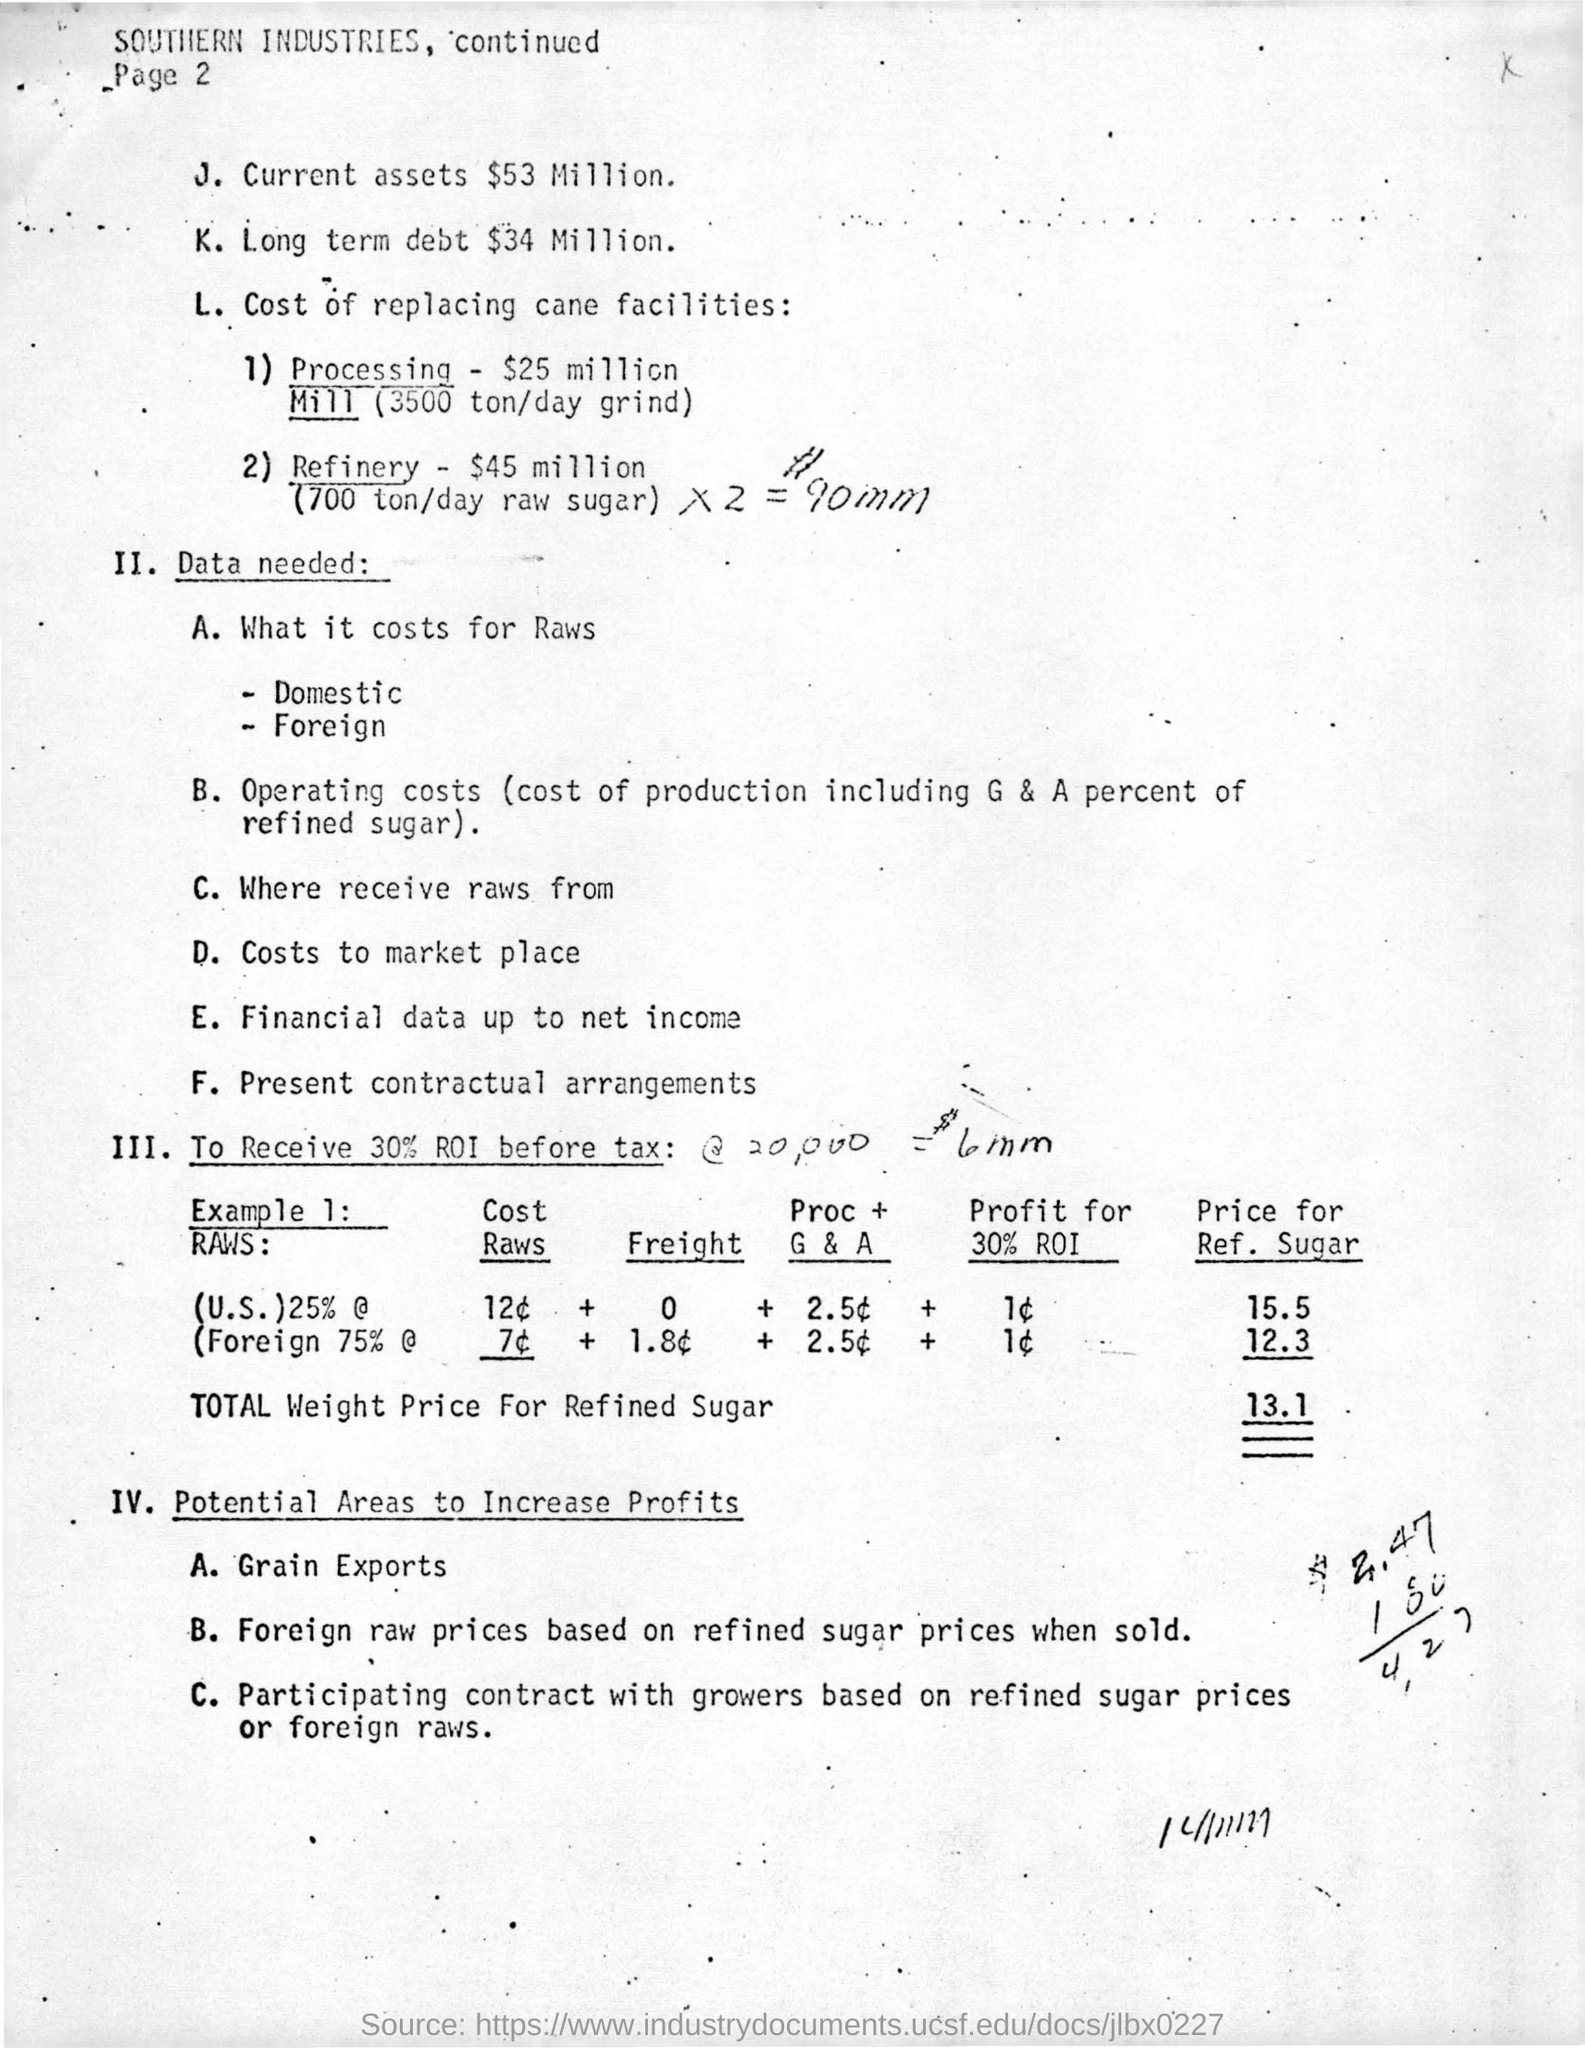What is the total weight price for refined sugar ?
Give a very brief answer. 13.1. What is the amount of current assets ?
Your answer should be very brief. $53 million. What is the amount of long term debt ?
Provide a short and direct response. $34 million. What is the cost of processing mill (3500 ton/day grind) ?
Offer a very short reply. $25 million. What is the name of the given industry ?
Make the answer very short. Southern industries. How much is the long term debt?
Your answer should be very brief. $34 Million. What ist the last point mentioned under "II. Data Needed:" ?
Provide a short and direct response. Present Contractual Arrangements. 